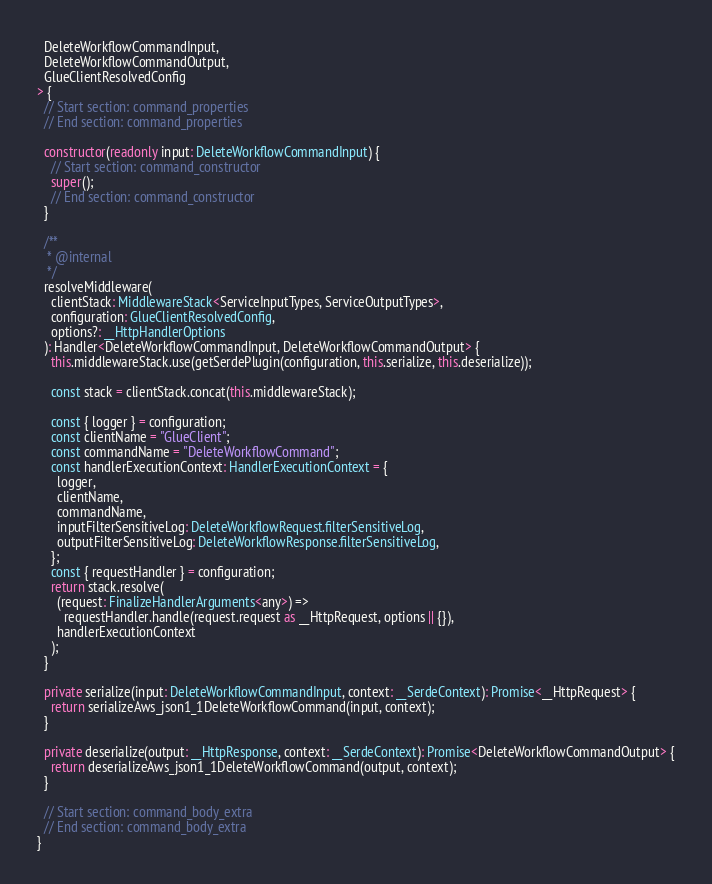Convert code to text. <code><loc_0><loc_0><loc_500><loc_500><_TypeScript_>  DeleteWorkflowCommandInput,
  DeleteWorkflowCommandOutput,
  GlueClientResolvedConfig
> {
  // Start section: command_properties
  // End section: command_properties

  constructor(readonly input: DeleteWorkflowCommandInput) {
    // Start section: command_constructor
    super();
    // End section: command_constructor
  }

  /**
   * @internal
   */
  resolveMiddleware(
    clientStack: MiddlewareStack<ServiceInputTypes, ServiceOutputTypes>,
    configuration: GlueClientResolvedConfig,
    options?: __HttpHandlerOptions
  ): Handler<DeleteWorkflowCommandInput, DeleteWorkflowCommandOutput> {
    this.middlewareStack.use(getSerdePlugin(configuration, this.serialize, this.deserialize));

    const stack = clientStack.concat(this.middlewareStack);

    const { logger } = configuration;
    const clientName = "GlueClient";
    const commandName = "DeleteWorkflowCommand";
    const handlerExecutionContext: HandlerExecutionContext = {
      logger,
      clientName,
      commandName,
      inputFilterSensitiveLog: DeleteWorkflowRequest.filterSensitiveLog,
      outputFilterSensitiveLog: DeleteWorkflowResponse.filterSensitiveLog,
    };
    const { requestHandler } = configuration;
    return stack.resolve(
      (request: FinalizeHandlerArguments<any>) =>
        requestHandler.handle(request.request as __HttpRequest, options || {}),
      handlerExecutionContext
    );
  }

  private serialize(input: DeleteWorkflowCommandInput, context: __SerdeContext): Promise<__HttpRequest> {
    return serializeAws_json1_1DeleteWorkflowCommand(input, context);
  }

  private deserialize(output: __HttpResponse, context: __SerdeContext): Promise<DeleteWorkflowCommandOutput> {
    return deserializeAws_json1_1DeleteWorkflowCommand(output, context);
  }

  // Start section: command_body_extra
  // End section: command_body_extra
}
</code> 